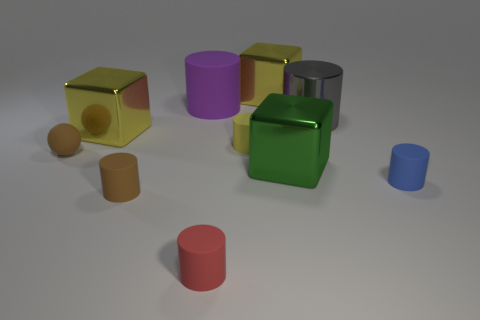Subtract all red matte cylinders. How many cylinders are left? 5 Subtract all yellow cubes. How many cubes are left? 1 Subtract all cubes. How many objects are left? 7 Add 9 red matte things. How many red matte things exist? 10 Subtract 1 yellow cylinders. How many objects are left? 9 Subtract 1 cylinders. How many cylinders are left? 5 Subtract all gray cylinders. Subtract all yellow balls. How many cylinders are left? 5 Subtract all red cylinders. How many cyan balls are left? 0 Subtract all metal cubes. Subtract all red matte things. How many objects are left? 6 Add 3 green blocks. How many green blocks are left? 4 